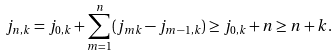<formula> <loc_0><loc_0><loc_500><loc_500>j _ { n , k } & = j _ { 0 , k } + \sum _ { m = 1 } ^ { n } ( j _ { m k } - j _ { m - 1 , k } ) \geq j _ { 0 , k } + n \geq n + k .</formula> 